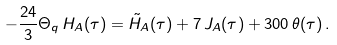<formula> <loc_0><loc_0><loc_500><loc_500>- \frac { 2 4 } { 3 } \Theta _ { q } \, H _ { A } ( \tau ) = \tilde { H } _ { A } ( \tau ) + 7 \, J _ { A } ( \tau ) + 3 0 0 \, \theta ( \tau ) \, .</formula> 